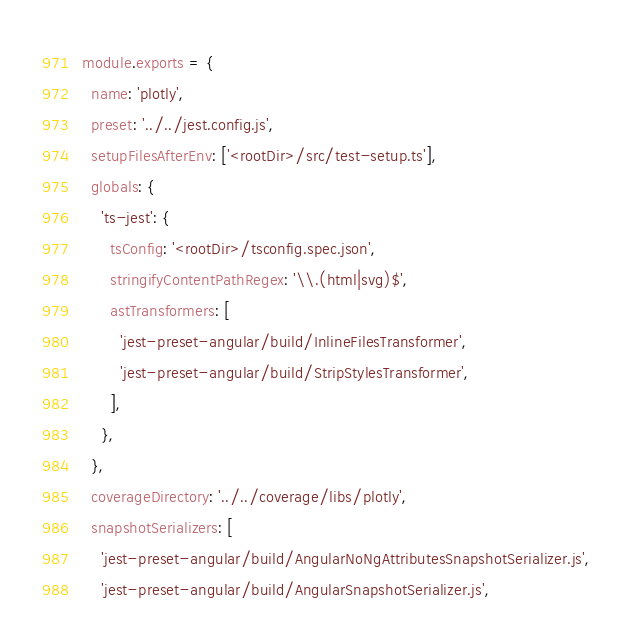<code> <loc_0><loc_0><loc_500><loc_500><_JavaScript_>module.exports = {
  name: 'plotly',
  preset: '../../jest.config.js',
  setupFilesAfterEnv: ['<rootDir>/src/test-setup.ts'],
  globals: {
    'ts-jest': {
      tsConfig: '<rootDir>/tsconfig.spec.json',
      stringifyContentPathRegex: '\\.(html|svg)$',
      astTransformers: [
        'jest-preset-angular/build/InlineFilesTransformer',
        'jest-preset-angular/build/StripStylesTransformer',
      ],
    },
  },
  coverageDirectory: '../../coverage/libs/plotly',
  snapshotSerializers: [
    'jest-preset-angular/build/AngularNoNgAttributesSnapshotSerializer.js',
    'jest-preset-angular/build/AngularSnapshotSerializer.js',</code> 